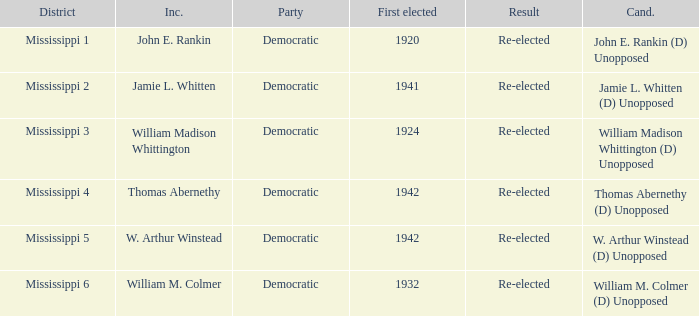What is the result for w. arthur winstead? Re-elected. 